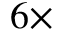<formula> <loc_0><loc_0><loc_500><loc_500>6 \times</formula> 